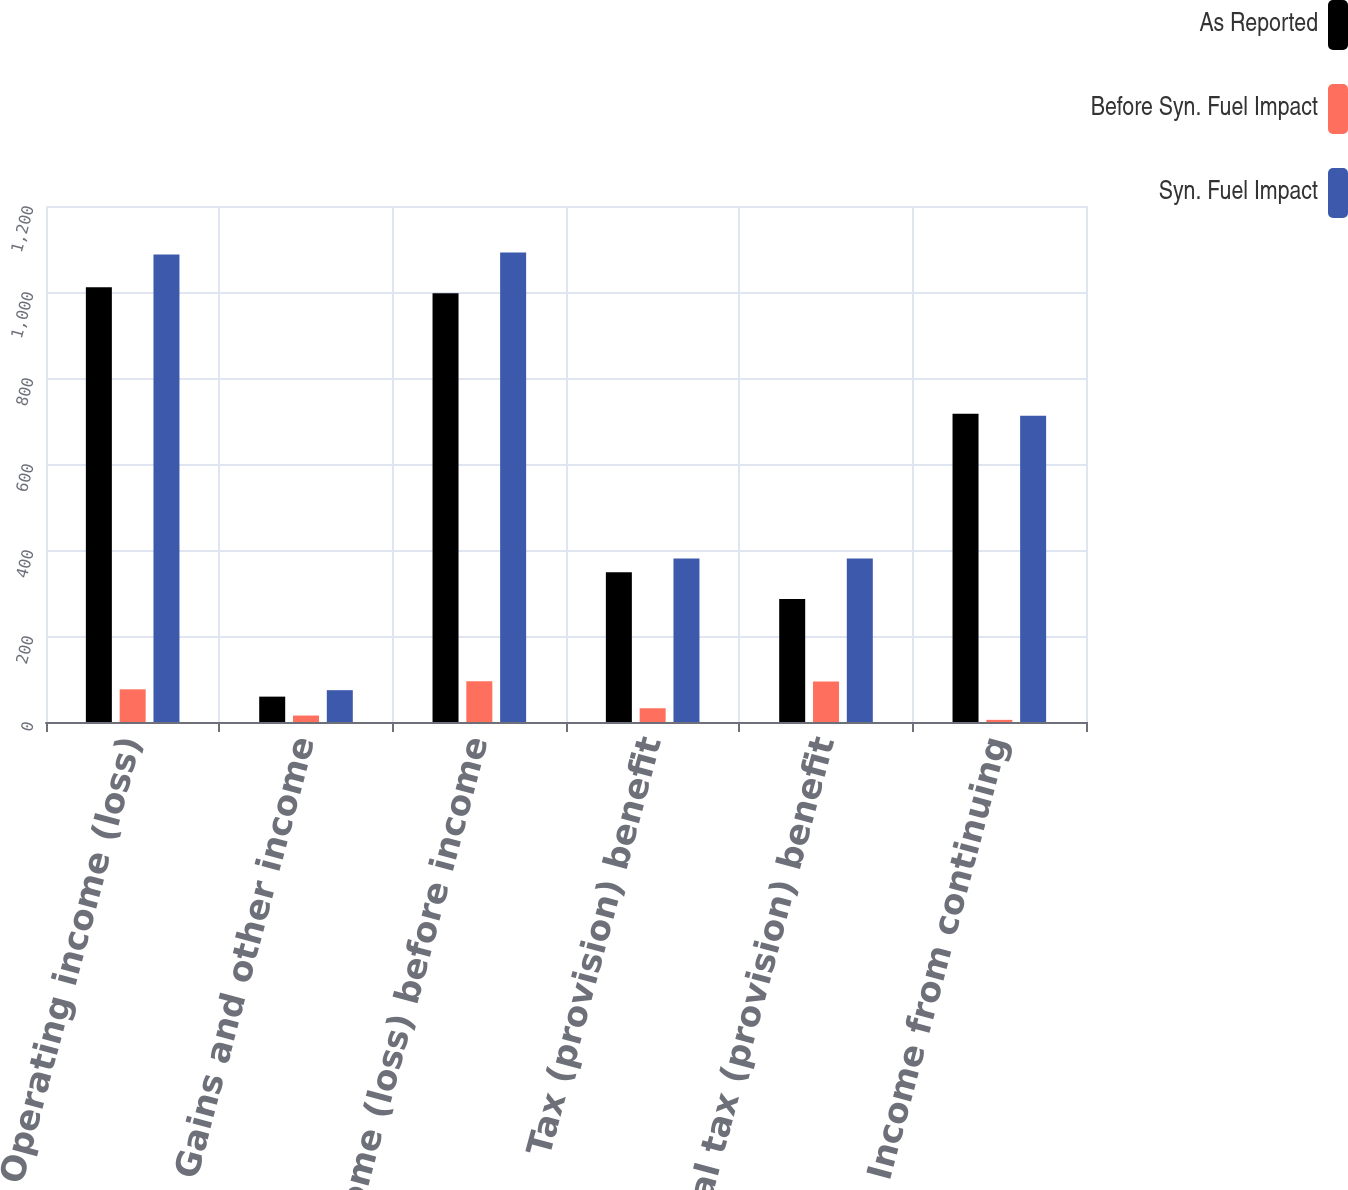Convert chart to OTSL. <chart><loc_0><loc_0><loc_500><loc_500><stacked_bar_chart><ecel><fcel>Operating income (loss)<fcel>Gains and other income<fcel>Income (loss) before income<fcel>Tax (provision) benefit<fcel>Total tax (provision) benefit<fcel>Income from continuing<nl><fcel>As Reported<fcel>1011<fcel>59<fcel>997<fcel>348<fcel>286<fcel>717<nl><fcel>Before Syn. Fuel Impact<fcel>76<fcel>15<fcel>95<fcel>32<fcel>94<fcel>5<nl><fcel>Syn. Fuel Impact<fcel>1087<fcel>74<fcel>1092<fcel>380<fcel>380<fcel>712<nl></chart> 